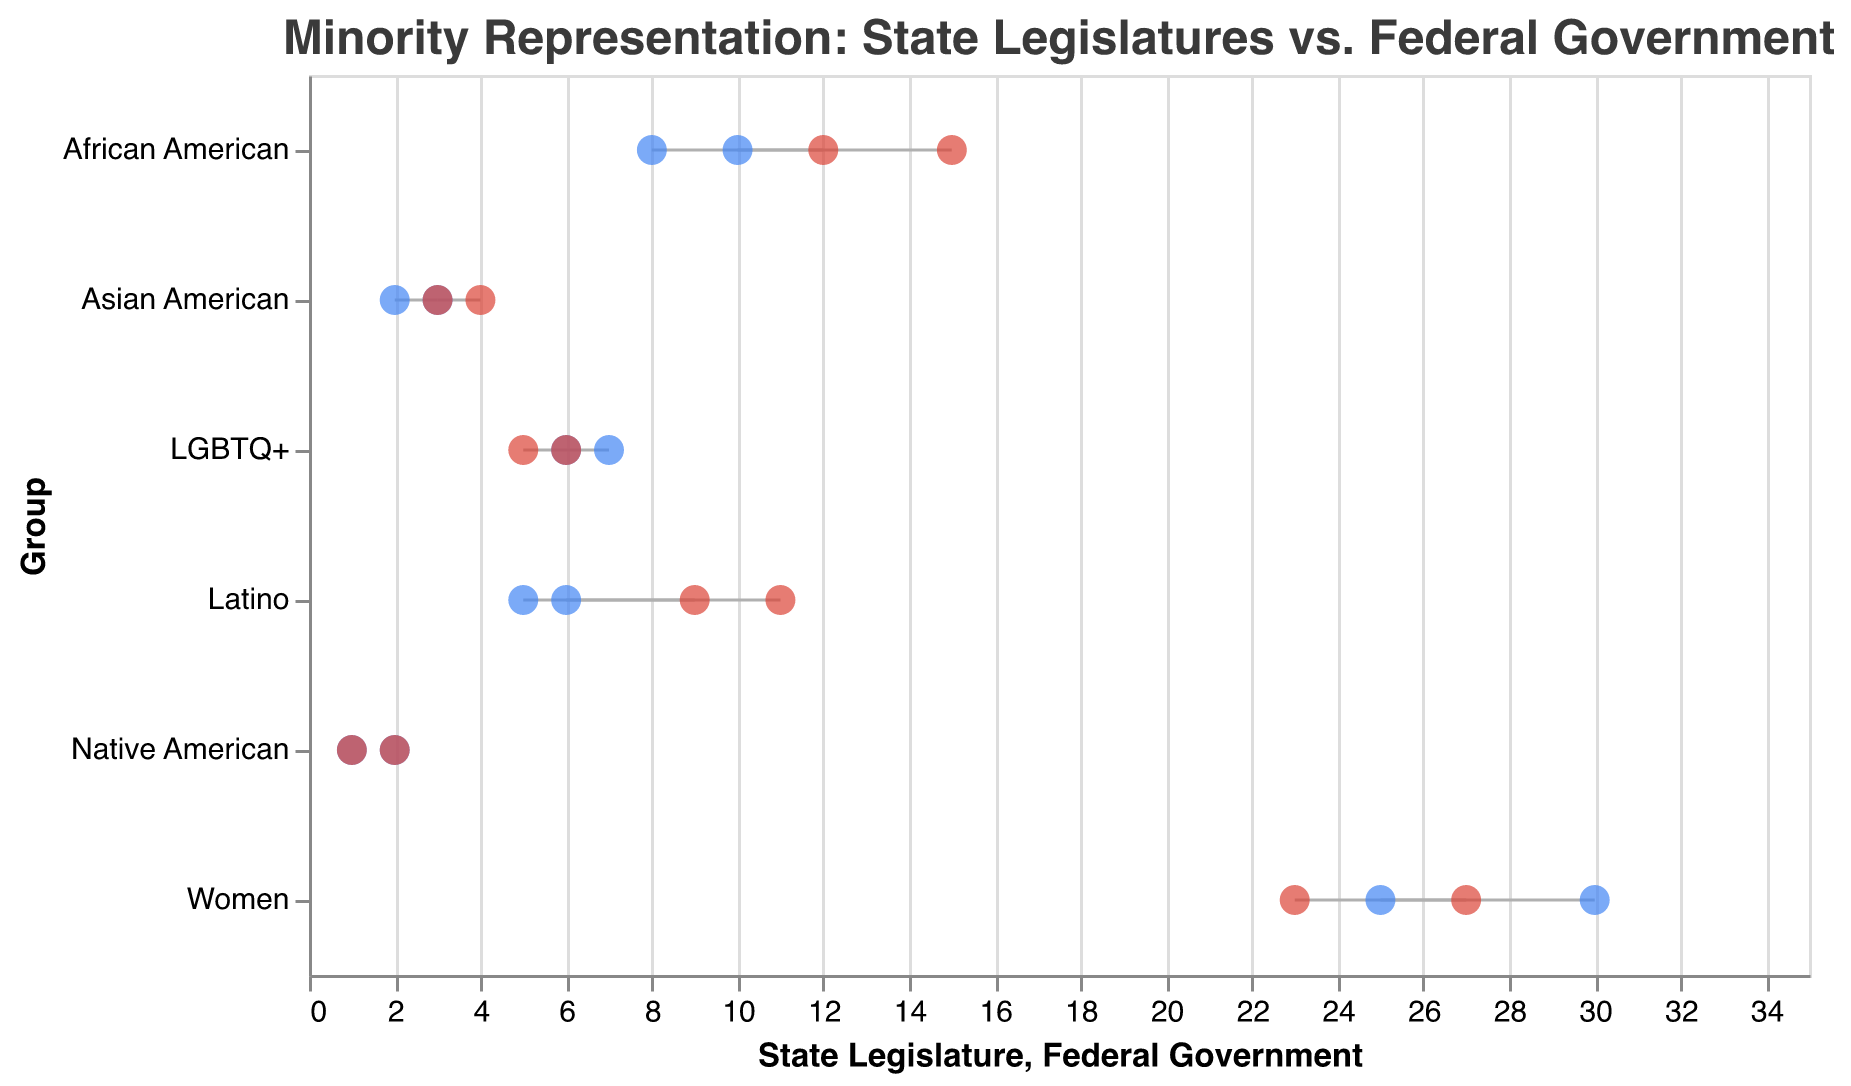What is the title of the figure? The title is displayed at the top of the figure in text and provides an overview of the chart's content.
Answer: Minority Representation: State Legislatures vs. Federal Government Which group has the lowest representation in both State Legislatures and the Federal Government? By looking at the y-axis and comparing the x-coordinates of the points, Native American representation is the lowest in both categories.
Answer: Native American Which group shows the largest difference in representation between the State Legislatures and the Federal Government? By comparing the differences between the points on the x-axis for each group, the African American group (8 vs 15) has the largest difference.
Answer: African American How many groups have higher representation in State Legislatures compared to the Federal Government? Compare the x-values for both State Legislature and Federal Government points for each group. There are four groups: LGBTQ+, Women, African American, and Native American.
Answer: 4 What is the representation of Women in the Federal Government? Look at the points corresponding to the Women category on the y-axis and check the x value specifically for the red point that denotes the Federal Government.
Answer: 27 Which group has an equal representation in both State Legislatures and the Federal Government? Identify the groups where both points align vertically on the x axis, indicating the same value.
Answer: Native American and LGBTQ+ What is the average representation of Latinos in the State Legislature? Summing up the Latino values in State Legislature (5 and 6) and dividing by the number of data points: (5 + 6) / 2 = 5.5.
Answer: 5.5 What is the median representation of African Americans in the Federal Government? Arrange African American representation values in the Federal Government (12, 15) and find the middle value.
Answer: 13.5 Between the Asian American and Latino groups, which one has a larger average representation in the Federal Government? Calculate averages for Asian American ([(3 + 4) / 2 = 3.5]) and Latino ([(9 + 11) / 2 = 10]) representation values in the Federal Government, then compare.
Answer: Latino 